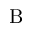Convert formula to latex. <formula><loc_0><loc_0><loc_500><loc_500>B</formula> 